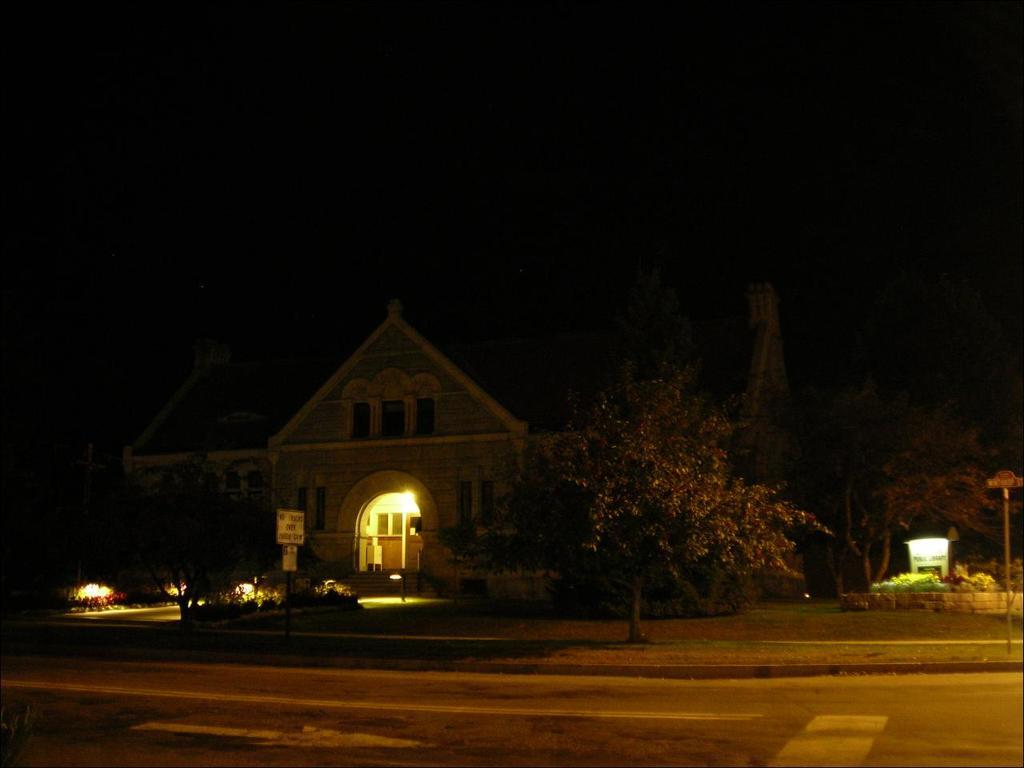What type of vegetation can be seen in the image? There are trees and plants in the image. What type of structure is present in the image? There is a house in the image. What objects are supporting something in the image? There are poles in the image that may be supporting something. What can be read or seen with text in the image? There is a board with text in the image. Can you tell me how many basketballs are visible in the image? There are no basketballs present in the image. What force is being applied to the plants in the image? There is no force being applied to the plants in the image; they are stationary. 